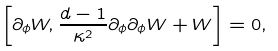Convert formula to latex. <formula><loc_0><loc_0><loc_500><loc_500>\left [ \partial _ { \phi } W , \frac { d - 1 } { \kappa ^ { 2 } } \partial _ { \phi } \partial _ { \phi } W + W \right ] = 0 ,</formula> 